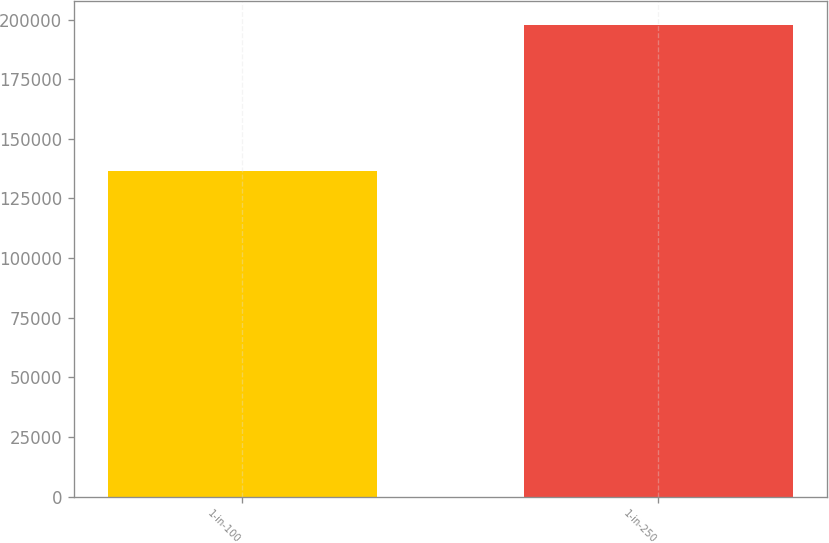Convert chart. <chart><loc_0><loc_0><loc_500><loc_500><bar_chart><fcel>1-in-100<fcel>1-in-250<nl><fcel>136665<fcel>197856<nl></chart> 